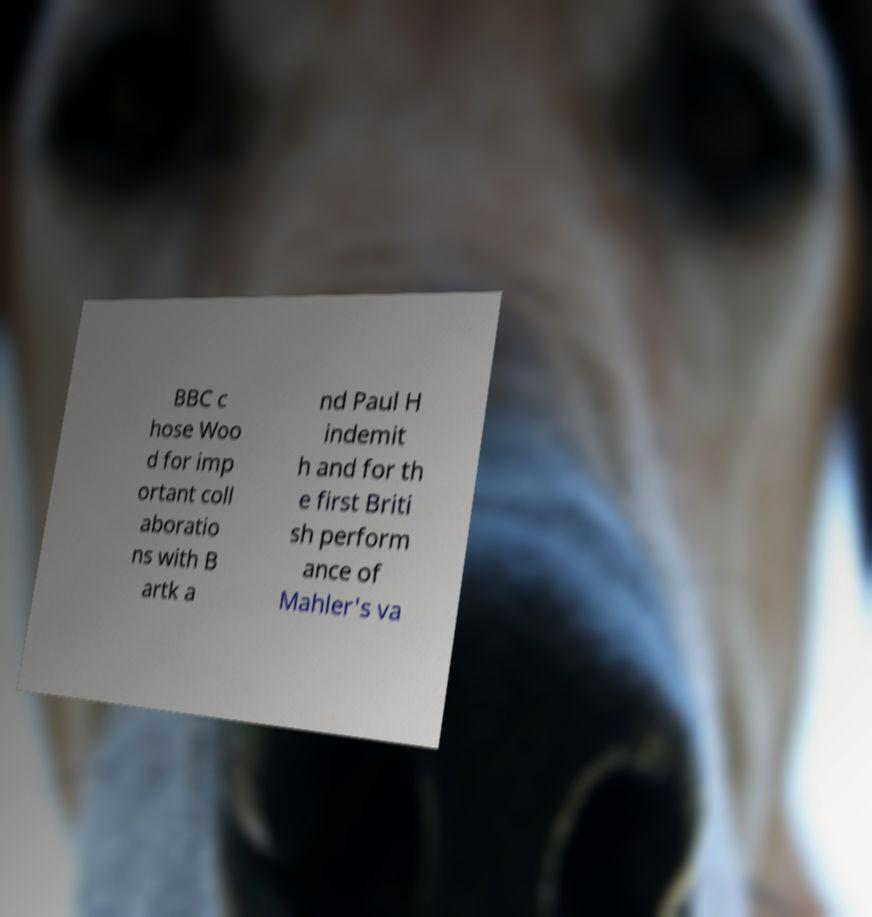Can you accurately transcribe the text from the provided image for me? BBC c hose Woo d for imp ortant coll aboratio ns with B artk a nd Paul H indemit h and for th e first Briti sh perform ance of Mahler's va 